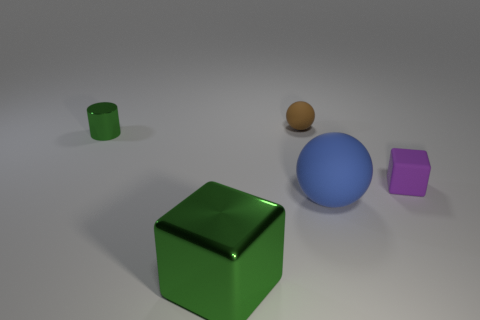What is the shape of the shiny object on the right side of the small green object?
Your answer should be very brief. Cube. What shape is the green object in front of the block that is on the right side of the small sphere?
Provide a succinct answer. Cube. What number of cyan objects are either shiny cylinders or tiny blocks?
Provide a short and direct response. 0. There is a tiny purple rubber block that is right of the rubber sphere in front of the small sphere; are there any cylinders in front of it?
Ensure brevity in your answer.  No. Is there anything else that is the same size as the metal cube?
Provide a short and direct response. Yes. Does the tiny cylinder have the same color as the tiny matte sphere?
Keep it short and to the point. No. There is a ball to the right of the matte object that is behind the metallic cylinder; what is its color?
Your response must be concise. Blue. What number of large objects are red matte cubes or brown rubber balls?
Offer a very short reply. 0. There is a tiny thing that is on the left side of the blue rubber ball and in front of the brown matte thing; what is its color?
Your answer should be compact. Green. Are the big green block and the cylinder made of the same material?
Keep it short and to the point. Yes. 